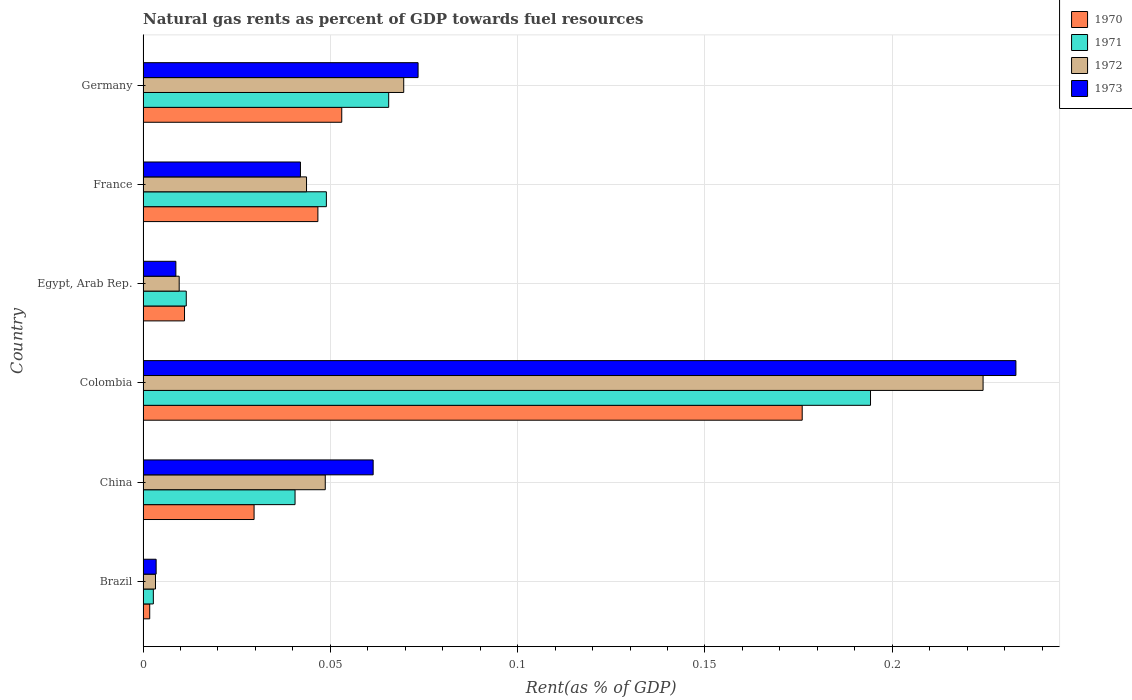How many different coloured bars are there?
Offer a terse response. 4. How many groups of bars are there?
Offer a very short reply. 6. Are the number of bars per tick equal to the number of legend labels?
Ensure brevity in your answer.  Yes. In how many cases, is the number of bars for a given country not equal to the number of legend labels?
Provide a short and direct response. 0. What is the matural gas rent in 1970 in Germany?
Your answer should be very brief. 0.05. Across all countries, what is the maximum matural gas rent in 1972?
Provide a succinct answer. 0.22. Across all countries, what is the minimum matural gas rent in 1971?
Your response must be concise. 0. In which country was the matural gas rent in 1973 maximum?
Your answer should be compact. Colombia. What is the total matural gas rent in 1972 in the graph?
Your response must be concise. 0.4. What is the difference between the matural gas rent in 1972 in Colombia and that in France?
Your answer should be compact. 0.18. What is the difference between the matural gas rent in 1972 in Egypt, Arab Rep. and the matural gas rent in 1970 in France?
Make the answer very short. -0.04. What is the average matural gas rent in 1972 per country?
Offer a very short reply. 0.07. What is the difference between the matural gas rent in 1971 and matural gas rent in 1973 in China?
Keep it short and to the point. -0.02. In how many countries, is the matural gas rent in 1972 greater than 0.09 %?
Your answer should be very brief. 1. What is the ratio of the matural gas rent in 1971 in Egypt, Arab Rep. to that in Germany?
Make the answer very short. 0.18. Is the matural gas rent in 1973 in Egypt, Arab Rep. less than that in Germany?
Give a very brief answer. Yes. Is the difference between the matural gas rent in 1971 in Colombia and France greater than the difference between the matural gas rent in 1973 in Colombia and France?
Your answer should be very brief. No. What is the difference between the highest and the second highest matural gas rent in 1972?
Make the answer very short. 0.15. What is the difference between the highest and the lowest matural gas rent in 1973?
Ensure brevity in your answer.  0.23. In how many countries, is the matural gas rent in 1970 greater than the average matural gas rent in 1970 taken over all countries?
Ensure brevity in your answer.  2. Is the sum of the matural gas rent in 1971 in Colombia and Germany greater than the maximum matural gas rent in 1972 across all countries?
Provide a short and direct response. Yes. Is it the case that in every country, the sum of the matural gas rent in 1970 and matural gas rent in 1971 is greater than the sum of matural gas rent in 1972 and matural gas rent in 1973?
Offer a very short reply. No. What does the 1st bar from the bottom in Germany represents?
Ensure brevity in your answer.  1970. How many bars are there?
Make the answer very short. 24. What is the difference between two consecutive major ticks on the X-axis?
Provide a succinct answer. 0.05. Does the graph contain any zero values?
Give a very brief answer. No. How are the legend labels stacked?
Make the answer very short. Vertical. What is the title of the graph?
Keep it short and to the point. Natural gas rents as percent of GDP towards fuel resources. Does "1979" appear as one of the legend labels in the graph?
Provide a short and direct response. No. What is the label or title of the X-axis?
Your response must be concise. Rent(as % of GDP). What is the Rent(as % of GDP) in 1970 in Brazil?
Your response must be concise. 0. What is the Rent(as % of GDP) in 1971 in Brazil?
Offer a terse response. 0. What is the Rent(as % of GDP) in 1972 in Brazil?
Your answer should be very brief. 0. What is the Rent(as % of GDP) of 1973 in Brazil?
Offer a terse response. 0. What is the Rent(as % of GDP) of 1970 in China?
Give a very brief answer. 0.03. What is the Rent(as % of GDP) in 1971 in China?
Provide a succinct answer. 0.04. What is the Rent(as % of GDP) in 1972 in China?
Ensure brevity in your answer.  0.05. What is the Rent(as % of GDP) of 1973 in China?
Provide a succinct answer. 0.06. What is the Rent(as % of GDP) of 1970 in Colombia?
Your response must be concise. 0.18. What is the Rent(as % of GDP) of 1971 in Colombia?
Provide a short and direct response. 0.19. What is the Rent(as % of GDP) in 1972 in Colombia?
Your answer should be compact. 0.22. What is the Rent(as % of GDP) of 1973 in Colombia?
Ensure brevity in your answer.  0.23. What is the Rent(as % of GDP) of 1970 in Egypt, Arab Rep.?
Your answer should be compact. 0.01. What is the Rent(as % of GDP) in 1971 in Egypt, Arab Rep.?
Make the answer very short. 0.01. What is the Rent(as % of GDP) in 1972 in Egypt, Arab Rep.?
Make the answer very short. 0.01. What is the Rent(as % of GDP) of 1973 in Egypt, Arab Rep.?
Offer a terse response. 0.01. What is the Rent(as % of GDP) of 1970 in France?
Give a very brief answer. 0.05. What is the Rent(as % of GDP) in 1971 in France?
Make the answer very short. 0.05. What is the Rent(as % of GDP) of 1972 in France?
Your answer should be very brief. 0.04. What is the Rent(as % of GDP) of 1973 in France?
Your answer should be compact. 0.04. What is the Rent(as % of GDP) in 1970 in Germany?
Your answer should be very brief. 0.05. What is the Rent(as % of GDP) in 1971 in Germany?
Offer a very short reply. 0.07. What is the Rent(as % of GDP) of 1972 in Germany?
Provide a succinct answer. 0.07. What is the Rent(as % of GDP) in 1973 in Germany?
Keep it short and to the point. 0.07. Across all countries, what is the maximum Rent(as % of GDP) in 1970?
Keep it short and to the point. 0.18. Across all countries, what is the maximum Rent(as % of GDP) in 1971?
Keep it short and to the point. 0.19. Across all countries, what is the maximum Rent(as % of GDP) in 1972?
Keep it short and to the point. 0.22. Across all countries, what is the maximum Rent(as % of GDP) of 1973?
Give a very brief answer. 0.23. Across all countries, what is the minimum Rent(as % of GDP) of 1970?
Make the answer very short. 0. Across all countries, what is the minimum Rent(as % of GDP) in 1971?
Keep it short and to the point. 0. Across all countries, what is the minimum Rent(as % of GDP) in 1972?
Ensure brevity in your answer.  0. Across all countries, what is the minimum Rent(as % of GDP) in 1973?
Make the answer very short. 0. What is the total Rent(as % of GDP) of 1970 in the graph?
Give a very brief answer. 0.32. What is the total Rent(as % of GDP) in 1971 in the graph?
Give a very brief answer. 0.36. What is the total Rent(as % of GDP) of 1972 in the graph?
Provide a short and direct response. 0.4. What is the total Rent(as % of GDP) of 1973 in the graph?
Your answer should be very brief. 0.42. What is the difference between the Rent(as % of GDP) in 1970 in Brazil and that in China?
Your answer should be very brief. -0.03. What is the difference between the Rent(as % of GDP) of 1971 in Brazil and that in China?
Your response must be concise. -0.04. What is the difference between the Rent(as % of GDP) in 1972 in Brazil and that in China?
Your answer should be very brief. -0.05. What is the difference between the Rent(as % of GDP) of 1973 in Brazil and that in China?
Provide a short and direct response. -0.06. What is the difference between the Rent(as % of GDP) of 1970 in Brazil and that in Colombia?
Offer a terse response. -0.17. What is the difference between the Rent(as % of GDP) of 1971 in Brazil and that in Colombia?
Keep it short and to the point. -0.19. What is the difference between the Rent(as % of GDP) in 1972 in Brazil and that in Colombia?
Provide a succinct answer. -0.22. What is the difference between the Rent(as % of GDP) in 1973 in Brazil and that in Colombia?
Your response must be concise. -0.23. What is the difference between the Rent(as % of GDP) of 1970 in Brazil and that in Egypt, Arab Rep.?
Give a very brief answer. -0.01. What is the difference between the Rent(as % of GDP) in 1971 in Brazil and that in Egypt, Arab Rep.?
Offer a terse response. -0.01. What is the difference between the Rent(as % of GDP) in 1972 in Brazil and that in Egypt, Arab Rep.?
Your response must be concise. -0.01. What is the difference between the Rent(as % of GDP) in 1973 in Brazil and that in Egypt, Arab Rep.?
Give a very brief answer. -0.01. What is the difference between the Rent(as % of GDP) of 1970 in Brazil and that in France?
Offer a very short reply. -0.04. What is the difference between the Rent(as % of GDP) in 1971 in Brazil and that in France?
Offer a very short reply. -0.05. What is the difference between the Rent(as % of GDP) in 1972 in Brazil and that in France?
Offer a very short reply. -0.04. What is the difference between the Rent(as % of GDP) in 1973 in Brazil and that in France?
Give a very brief answer. -0.04. What is the difference between the Rent(as % of GDP) in 1970 in Brazil and that in Germany?
Provide a succinct answer. -0.05. What is the difference between the Rent(as % of GDP) of 1971 in Brazil and that in Germany?
Provide a short and direct response. -0.06. What is the difference between the Rent(as % of GDP) of 1972 in Brazil and that in Germany?
Your answer should be very brief. -0.07. What is the difference between the Rent(as % of GDP) of 1973 in Brazil and that in Germany?
Offer a very short reply. -0.07. What is the difference between the Rent(as % of GDP) of 1970 in China and that in Colombia?
Give a very brief answer. -0.15. What is the difference between the Rent(as % of GDP) in 1971 in China and that in Colombia?
Your response must be concise. -0.15. What is the difference between the Rent(as % of GDP) in 1972 in China and that in Colombia?
Your response must be concise. -0.18. What is the difference between the Rent(as % of GDP) in 1973 in China and that in Colombia?
Provide a succinct answer. -0.17. What is the difference between the Rent(as % of GDP) in 1970 in China and that in Egypt, Arab Rep.?
Provide a succinct answer. 0.02. What is the difference between the Rent(as % of GDP) of 1971 in China and that in Egypt, Arab Rep.?
Your answer should be very brief. 0.03. What is the difference between the Rent(as % of GDP) of 1972 in China and that in Egypt, Arab Rep.?
Your answer should be compact. 0.04. What is the difference between the Rent(as % of GDP) in 1973 in China and that in Egypt, Arab Rep.?
Provide a succinct answer. 0.05. What is the difference between the Rent(as % of GDP) in 1970 in China and that in France?
Provide a short and direct response. -0.02. What is the difference between the Rent(as % of GDP) in 1971 in China and that in France?
Give a very brief answer. -0.01. What is the difference between the Rent(as % of GDP) of 1972 in China and that in France?
Give a very brief answer. 0.01. What is the difference between the Rent(as % of GDP) of 1973 in China and that in France?
Your answer should be compact. 0.02. What is the difference between the Rent(as % of GDP) in 1970 in China and that in Germany?
Your answer should be compact. -0.02. What is the difference between the Rent(as % of GDP) of 1971 in China and that in Germany?
Provide a succinct answer. -0.03. What is the difference between the Rent(as % of GDP) of 1972 in China and that in Germany?
Ensure brevity in your answer.  -0.02. What is the difference between the Rent(as % of GDP) of 1973 in China and that in Germany?
Give a very brief answer. -0.01. What is the difference between the Rent(as % of GDP) in 1970 in Colombia and that in Egypt, Arab Rep.?
Offer a terse response. 0.16. What is the difference between the Rent(as % of GDP) in 1971 in Colombia and that in Egypt, Arab Rep.?
Offer a terse response. 0.18. What is the difference between the Rent(as % of GDP) in 1972 in Colombia and that in Egypt, Arab Rep.?
Keep it short and to the point. 0.21. What is the difference between the Rent(as % of GDP) of 1973 in Colombia and that in Egypt, Arab Rep.?
Provide a succinct answer. 0.22. What is the difference between the Rent(as % of GDP) of 1970 in Colombia and that in France?
Keep it short and to the point. 0.13. What is the difference between the Rent(as % of GDP) of 1971 in Colombia and that in France?
Offer a very short reply. 0.15. What is the difference between the Rent(as % of GDP) in 1972 in Colombia and that in France?
Provide a succinct answer. 0.18. What is the difference between the Rent(as % of GDP) in 1973 in Colombia and that in France?
Keep it short and to the point. 0.19. What is the difference between the Rent(as % of GDP) in 1970 in Colombia and that in Germany?
Your answer should be compact. 0.12. What is the difference between the Rent(as % of GDP) in 1971 in Colombia and that in Germany?
Your answer should be compact. 0.13. What is the difference between the Rent(as % of GDP) in 1972 in Colombia and that in Germany?
Your answer should be very brief. 0.15. What is the difference between the Rent(as % of GDP) in 1973 in Colombia and that in Germany?
Offer a terse response. 0.16. What is the difference between the Rent(as % of GDP) of 1970 in Egypt, Arab Rep. and that in France?
Keep it short and to the point. -0.04. What is the difference between the Rent(as % of GDP) in 1971 in Egypt, Arab Rep. and that in France?
Your answer should be compact. -0.04. What is the difference between the Rent(as % of GDP) of 1972 in Egypt, Arab Rep. and that in France?
Provide a short and direct response. -0.03. What is the difference between the Rent(as % of GDP) in 1973 in Egypt, Arab Rep. and that in France?
Your answer should be very brief. -0.03. What is the difference between the Rent(as % of GDP) in 1970 in Egypt, Arab Rep. and that in Germany?
Ensure brevity in your answer.  -0.04. What is the difference between the Rent(as % of GDP) in 1971 in Egypt, Arab Rep. and that in Germany?
Keep it short and to the point. -0.05. What is the difference between the Rent(as % of GDP) of 1972 in Egypt, Arab Rep. and that in Germany?
Your answer should be compact. -0.06. What is the difference between the Rent(as % of GDP) in 1973 in Egypt, Arab Rep. and that in Germany?
Offer a very short reply. -0.06. What is the difference between the Rent(as % of GDP) in 1970 in France and that in Germany?
Provide a short and direct response. -0.01. What is the difference between the Rent(as % of GDP) in 1971 in France and that in Germany?
Offer a terse response. -0.02. What is the difference between the Rent(as % of GDP) of 1972 in France and that in Germany?
Offer a very short reply. -0.03. What is the difference between the Rent(as % of GDP) in 1973 in France and that in Germany?
Offer a very short reply. -0.03. What is the difference between the Rent(as % of GDP) of 1970 in Brazil and the Rent(as % of GDP) of 1971 in China?
Your response must be concise. -0.04. What is the difference between the Rent(as % of GDP) in 1970 in Brazil and the Rent(as % of GDP) in 1972 in China?
Your response must be concise. -0.05. What is the difference between the Rent(as % of GDP) in 1970 in Brazil and the Rent(as % of GDP) in 1973 in China?
Your answer should be very brief. -0.06. What is the difference between the Rent(as % of GDP) in 1971 in Brazil and the Rent(as % of GDP) in 1972 in China?
Provide a short and direct response. -0.05. What is the difference between the Rent(as % of GDP) in 1971 in Brazil and the Rent(as % of GDP) in 1973 in China?
Give a very brief answer. -0.06. What is the difference between the Rent(as % of GDP) in 1972 in Brazil and the Rent(as % of GDP) in 1973 in China?
Your answer should be very brief. -0.06. What is the difference between the Rent(as % of GDP) of 1970 in Brazil and the Rent(as % of GDP) of 1971 in Colombia?
Offer a terse response. -0.19. What is the difference between the Rent(as % of GDP) of 1970 in Brazil and the Rent(as % of GDP) of 1972 in Colombia?
Your answer should be compact. -0.22. What is the difference between the Rent(as % of GDP) of 1970 in Brazil and the Rent(as % of GDP) of 1973 in Colombia?
Provide a succinct answer. -0.23. What is the difference between the Rent(as % of GDP) in 1971 in Brazil and the Rent(as % of GDP) in 1972 in Colombia?
Offer a very short reply. -0.22. What is the difference between the Rent(as % of GDP) in 1971 in Brazil and the Rent(as % of GDP) in 1973 in Colombia?
Keep it short and to the point. -0.23. What is the difference between the Rent(as % of GDP) in 1972 in Brazil and the Rent(as % of GDP) in 1973 in Colombia?
Offer a terse response. -0.23. What is the difference between the Rent(as % of GDP) of 1970 in Brazil and the Rent(as % of GDP) of 1971 in Egypt, Arab Rep.?
Keep it short and to the point. -0.01. What is the difference between the Rent(as % of GDP) in 1970 in Brazil and the Rent(as % of GDP) in 1972 in Egypt, Arab Rep.?
Provide a short and direct response. -0.01. What is the difference between the Rent(as % of GDP) of 1970 in Brazil and the Rent(as % of GDP) of 1973 in Egypt, Arab Rep.?
Provide a succinct answer. -0.01. What is the difference between the Rent(as % of GDP) of 1971 in Brazil and the Rent(as % of GDP) of 1972 in Egypt, Arab Rep.?
Offer a terse response. -0.01. What is the difference between the Rent(as % of GDP) in 1971 in Brazil and the Rent(as % of GDP) in 1973 in Egypt, Arab Rep.?
Your response must be concise. -0.01. What is the difference between the Rent(as % of GDP) of 1972 in Brazil and the Rent(as % of GDP) of 1973 in Egypt, Arab Rep.?
Offer a very short reply. -0.01. What is the difference between the Rent(as % of GDP) of 1970 in Brazil and the Rent(as % of GDP) of 1971 in France?
Ensure brevity in your answer.  -0.05. What is the difference between the Rent(as % of GDP) of 1970 in Brazil and the Rent(as % of GDP) of 1972 in France?
Ensure brevity in your answer.  -0.04. What is the difference between the Rent(as % of GDP) of 1970 in Brazil and the Rent(as % of GDP) of 1973 in France?
Provide a succinct answer. -0.04. What is the difference between the Rent(as % of GDP) of 1971 in Brazil and the Rent(as % of GDP) of 1972 in France?
Offer a terse response. -0.04. What is the difference between the Rent(as % of GDP) in 1971 in Brazil and the Rent(as % of GDP) in 1973 in France?
Provide a short and direct response. -0.04. What is the difference between the Rent(as % of GDP) in 1972 in Brazil and the Rent(as % of GDP) in 1973 in France?
Give a very brief answer. -0.04. What is the difference between the Rent(as % of GDP) of 1970 in Brazil and the Rent(as % of GDP) of 1971 in Germany?
Give a very brief answer. -0.06. What is the difference between the Rent(as % of GDP) in 1970 in Brazil and the Rent(as % of GDP) in 1972 in Germany?
Your response must be concise. -0.07. What is the difference between the Rent(as % of GDP) of 1970 in Brazil and the Rent(as % of GDP) of 1973 in Germany?
Make the answer very short. -0.07. What is the difference between the Rent(as % of GDP) of 1971 in Brazil and the Rent(as % of GDP) of 1972 in Germany?
Your answer should be very brief. -0.07. What is the difference between the Rent(as % of GDP) of 1971 in Brazil and the Rent(as % of GDP) of 1973 in Germany?
Keep it short and to the point. -0.07. What is the difference between the Rent(as % of GDP) of 1972 in Brazil and the Rent(as % of GDP) of 1973 in Germany?
Your answer should be compact. -0.07. What is the difference between the Rent(as % of GDP) of 1970 in China and the Rent(as % of GDP) of 1971 in Colombia?
Provide a short and direct response. -0.16. What is the difference between the Rent(as % of GDP) of 1970 in China and the Rent(as % of GDP) of 1972 in Colombia?
Ensure brevity in your answer.  -0.19. What is the difference between the Rent(as % of GDP) in 1970 in China and the Rent(as % of GDP) in 1973 in Colombia?
Offer a terse response. -0.2. What is the difference between the Rent(as % of GDP) of 1971 in China and the Rent(as % of GDP) of 1972 in Colombia?
Your answer should be compact. -0.18. What is the difference between the Rent(as % of GDP) in 1971 in China and the Rent(as % of GDP) in 1973 in Colombia?
Make the answer very short. -0.19. What is the difference between the Rent(as % of GDP) in 1972 in China and the Rent(as % of GDP) in 1973 in Colombia?
Your answer should be very brief. -0.18. What is the difference between the Rent(as % of GDP) in 1970 in China and the Rent(as % of GDP) in 1971 in Egypt, Arab Rep.?
Keep it short and to the point. 0.02. What is the difference between the Rent(as % of GDP) in 1970 in China and the Rent(as % of GDP) in 1972 in Egypt, Arab Rep.?
Offer a very short reply. 0.02. What is the difference between the Rent(as % of GDP) of 1970 in China and the Rent(as % of GDP) of 1973 in Egypt, Arab Rep.?
Your response must be concise. 0.02. What is the difference between the Rent(as % of GDP) of 1971 in China and the Rent(as % of GDP) of 1972 in Egypt, Arab Rep.?
Your answer should be compact. 0.03. What is the difference between the Rent(as % of GDP) in 1971 in China and the Rent(as % of GDP) in 1973 in Egypt, Arab Rep.?
Your response must be concise. 0.03. What is the difference between the Rent(as % of GDP) in 1972 in China and the Rent(as % of GDP) in 1973 in Egypt, Arab Rep.?
Provide a succinct answer. 0.04. What is the difference between the Rent(as % of GDP) of 1970 in China and the Rent(as % of GDP) of 1971 in France?
Your answer should be compact. -0.02. What is the difference between the Rent(as % of GDP) in 1970 in China and the Rent(as % of GDP) in 1972 in France?
Provide a succinct answer. -0.01. What is the difference between the Rent(as % of GDP) in 1970 in China and the Rent(as % of GDP) in 1973 in France?
Keep it short and to the point. -0.01. What is the difference between the Rent(as % of GDP) in 1971 in China and the Rent(as % of GDP) in 1972 in France?
Provide a short and direct response. -0. What is the difference between the Rent(as % of GDP) in 1971 in China and the Rent(as % of GDP) in 1973 in France?
Offer a terse response. -0. What is the difference between the Rent(as % of GDP) of 1972 in China and the Rent(as % of GDP) of 1973 in France?
Provide a short and direct response. 0.01. What is the difference between the Rent(as % of GDP) of 1970 in China and the Rent(as % of GDP) of 1971 in Germany?
Offer a very short reply. -0.04. What is the difference between the Rent(as % of GDP) of 1970 in China and the Rent(as % of GDP) of 1972 in Germany?
Your answer should be compact. -0.04. What is the difference between the Rent(as % of GDP) of 1970 in China and the Rent(as % of GDP) of 1973 in Germany?
Ensure brevity in your answer.  -0.04. What is the difference between the Rent(as % of GDP) of 1971 in China and the Rent(as % of GDP) of 1972 in Germany?
Your answer should be compact. -0.03. What is the difference between the Rent(as % of GDP) of 1971 in China and the Rent(as % of GDP) of 1973 in Germany?
Offer a very short reply. -0.03. What is the difference between the Rent(as % of GDP) in 1972 in China and the Rent(as % of GDP) in 1973 in Germany?
Provide a short and direct response. -0.02. What is the difference between the Rent(as % of GDP) of 1970 in Colombia and the Rent(as % of GDP) of 1971 in Egypt, Arab Rep.?
Offer a very short reply. 0.16. What is the difference between the Rent(as % of GDP) in 1970 in Colombia and the Rent(as % of GDP) in 1972 in Egypt, Arab Rep.?
Offer a terse response. 0.17. What is the difference between the Rent(as % of GDP) in 1970 in Colombia and the Rent(as % of GDP) in 1973 in Egypt, Arab Rep.?
Make the answer very short. 0.17. What is the difference between the Rent(as % of GDP) of 1971 in Colombia and the Rent(as % of GDP) of 1972 in Egypt, Arab Rep.?
Your answer should be very brief. 0.18. What is the difference between the Rent(as % of GDP) in 1971 in Colombia and the Rent(as % of GDP) in 1973 in Egypt, Arab Rep.?
Your answer should be compact. 0.19. What is the difference between the Rent(as % of GDP) of 1972 in Colombia and the Rent(as % of GDP) of 1973 in Egypt, Arab Rep.?
Offer a very short reply. 0.22. What is the difference between the Rent(as % of GDP) in 1970 in Colombia and the Rent(as % of GDP) in 1971 in France?
Your response must be concise. 0.13. What is the difference between the Rent(as % of GDP) of 1970 in Colombia and the Rent(as % of GDP) of 1972 in France?
Make the answer very short. 0.13. What is the difference between the Rent(as % of GDP) of 1970 in Colombia and the Rent(as % of GDP) of 1973 in France?
Your answer should be very brief. 0.13. What is the difference between the Rent(as % of GDP) of 1971 in Colombia and the Rent(as % of GDP) of 1972 in France?
Give a very brief answer. 0.15. What is the difference between the Rent(as % of GDP) of 1971 in Colombia and the Rent(as % of GDP) of 1973 in France?
Ensure brevity in your answer.  0.15. What is the difference between the Rent(as % of GDP) in 1972 in Colombia and the Rent(as % of GDP) in 1973 in France?
Give a very brief answer. 0.18. What is the difference between the Rent(as % of GDP) of 1970 in Colombia and the Rent(as % of GDP) of 1971 in Germany?
Offer a very short reply. 0.11. What is the difference between the Rent(as % of GDP) in 1970 in Colombia and the Rent(as % of GDP) in 1972 in Germany?
Make the answer very short. 0.11. What is the difference between the Rent(as % of GDP) in 1970 in Colombia and the Rent(as % of GDP) in 1973 in Germany?
Your answer should be compact. 0.1. What is the difference between the Rent(as % of GDP) in 1971 in Colombia and the Rent(as % of GDP) in 1972 in Germany?
Provide a short and direct response. 0.12. What is the difference between the Rent(as % of GDP) of 1971 in Colombia and the Rent(as % of GDP) of 1973 in Germany?
Give a very brief answer. 0.12. What is the difference between the Rent(as % of GDP) of 1972 in Colombia and the Rent(as % of GDP) of 1973 in Germany?
Provide a succinct answer. 0.15. What is the difference between the Rent(as % of GDP) of 1970 in Egypt, Arab Rep. and the Rent(as % of GDP) of 1971 in France?
Make the answer very short. -0.04. What is the difference between the Rent(as % of GDP) of 1970 in Egypt, Arab Rep. and the Rent(as % of GDP) of 1972 in France?
Keep it short and to the point. -0.03. What is the difference between the Rent(as % of GDP) of 1970 in Egypt, Arab Rep. and the Rent(as % of GDP) of 1973 in France?
Your answer should be compact. -0.03. What is the difference between the Rent(as % of GDP) of 1971 in Egypt, Arab Rep. and the Rent(as % of GDP) of 1972 in France?
Offer a terse response. -0.03. What is the difference between the Rent(as % of GDP) of 1971 in Egypt, Arab Rep. and the Rent(as % of GDP) of 1973 in France?
Provide a short and direct response. -0.03. What is the difference between the Rent(as % of GDP) of 1972 in Egypt, Arab Rep. and the Rent(as % of GDP) of 1973 in France?
Your answer should be compact. -0.03. What is the difference between the Rent(as % of GDP) in 1970 in Egypt, Arab Rep. and the Rent(as % of GDP) in 1971 in Germany?
Make the answer very short. -0.05. What is the difference between the Rent(as % of GDP) in 1970 in Egypt, Arab Rep. and the Rent(as % of GDP) in 1972 in Germany?
Make the answer very short. -0.06. What is the difference between the Rent(as % of GDP) of 1970 in Egypt, Arab Rep. and the Rent(as % of GDP) of 1973 in Germany?
Offer a very short reply. -0.06. What is the difference between the Rent(as % of GDP) in 1971 in Egypt, Arab Rep. and the Rent(as % of GDP) in 1972 in Germany?
Your answer should be very brief. -0.06. What is the difference between the Rent(as % of GDP) of 1971 in Egypt, Arab Rep. and the Rent(as % of GDP) of 1973 in Germany?
Provide a succinct answer. -0.06. What is the difference between the Rent(as % of GDP) in 1972 in Egypt, Arab Rep. and the Rent(as % of GDP) in 1973 in Germany?
Offer a terse response. -0.06. What is the difference between the Rent(as % of GDP) of 1970 in France and the Rent(as % of GDP) of 1971 in Germany?
Your answer should be very brief. -0.02. What is the difference between the Rent(as % of GDP) of 1970 in France and the Rent(as % of GDP) of 1972 in Germany?
Your response must be concise. -0.02. What is the difference between the Rent(as % of GDP) in 1970 in France and the Rent(as % of GDP) in 1973 in Germany?
Keep it short and to the point. -0.03. What is the difference between the Rent(as % of GDP) in 1971 in France and the Rent(as % of GDP) in 1972 in Germany?
Provide a short and direct response. -0.02. What is the difference between the Rent(as % of GDP) in 1971 in France and the Rent(as % of GDP) in 1973 in Germany?
Your answer should be compact. -0.02. What is the difference between the Rent(as % of GDP) of 1972 in France and the Rent(as % of GDP) of 1973 in Germany?
Keep it short and to the point. -0.03. What is the average Rent(as % of GDP) of 1970 per country?
Keep it short and to the point. 0.05. What is the average Rent(as % of GDP) of 1971 per country?
Give a very brief answer. 0.06. What is the average Rent(as % of GDP) of 1972 per country?
Provide a short and direct response. 0.07. What is the average Rent(as % of GDP) of 1973 per country?
Your response must be concise. 0.07. What is the difference between the Rent(as % of GDP) in 1970 and Rent(as % of GDP) in 1971 in Brazil?
Your answer should be compact. -0. What is the difference between the Rent(as % of GDP) in 1970 and Rent(as % of GDP) in 1972 in Brazil?
Ensure brevity in your answer.  -0. What is the difference between the Rent(as % of GDP) in 1970 and Rent(as % of GDP) in 1973 in Brazil?
Your answer should be very brief. -0. What is the difference between the Rent(as % of GDP) in 1971 and Rent(as % of GDP) in 1972 in Brazil?
Offer a terse response. -0. What is the difference between the Rent(as % of GDP) in 1971 and Rent(as % of GDP) in 1973 in Brazil?
Your answer should be compact. -0. What is the difference between the Rent(as % of GDP) in 1972 and Rent(as % of GDP) in 1973 in Brazil?
Provide a succinct answer. -0. What is the difference between the Rent(as % of GDP) in 1970 and Rent(as % of GDP) in 1971 in China?
Make the answer very short. -0.01. What is the difference between the Rent(as % of GDP) of 1970 and Rent(as % of GDP) of 1972 in China?
Provide a short and direct response. -0.02. What is the difference between the Rent(as % of GDP) of 1970 and Rent(as % of GDP) of 1973 in China?
Keep it short and to the point. -0.03. What is the difference between the Rent(as % of GDP) of 1971 and Rent(as % of GDP) of 1972 in China?
Your response must be concise. -0.01. What is the difference between the Rent(as % of GDP) of 1971 and Rent(as % of GDP) of 1973 in China?
Make the answer very short. -0.02. What is the difference between the Rent(as % of GDP) in 1972 and Rent(as % of GDP) in 1973 in China?
Keep it short and to the point. -0.01. What is the difference between the Rent(as % of GDP) in 1970 and Rent(as % of GDP) in 1971 in Colombia?
Keep it short and to the point. -0.02. What is the difference between the Rent(as % of GDP) in 1970 and Rent(as % of GDP) in 1972 in Colombia?
Keep it short and to the point. -0.05. What is the difference between the Rent(as % of GDP) of 1970 and Rent(as % of GDP) of 1973 in Colombia?
Provide a short and direct response. -0.06. What is the difference between the Rent(as % of GDP) of 1971 and Rent(as % of GDP) of 1972 in Colombia?
Provide a short and direct response. -0.03. What is the difference between the Rent(as % of GDP) in 1971 and Rent(as % of GDP) in 1973 in Colombia?
Your response must be concise. -0.04. What is the difference between the Rent(as % of GDP) of 1972 and Rent(as % of GDP) of 1973 in Colombia?
Your answer should be very brief. -0.01. What is the difference between the Rent(as % of GDP) in 1970 and Rent(as % of GDP) in 1971 in Egypt, Arab Rep.?
Provide a succinct answer. -0. What is the difference between the Rent(as % of GDP) in 1970 and Rent(as % of GDP) in 1972 in Egypt, Arab Rep.?
Your answer should be compact. 0. What is the difference between the Rent(as % of GDP) in 1970 and Rent(as % of GDP) in 1973 in Egypt, Arab Rep.?
Provide a succinct answer. 0. What is the difference between the Rent(as % of GDP) of 1971 and Rent(as % of GDP) of 1972 in Egypt, Arab Rep.?
Give a very brief answer. 0. What is the difference between the Rent(as % of GDP) in 1971 and Rent(as % of GDP) in 1973 in Egypt, Arab Rep.?
Provide a succinct answer. 0. What is the difference between the Rent(as % of GDP) of 1972 and Rent(as % of GDP) of 1973 in Egypt, Arab Rep.?
Give a very brief answer. 0. What is the difference between the Rent(as % of GDP) of 1970 and Rent(as % of GDP) of 1971 in France?
Provide a succinct answer. -0. What is the difference between the Rent(as % of GDP) of 1970 and Rent(as % of GDP) of 1972 in France?
Your response must be concise. 0. What is the difference between the Rent(as % of GDP) of 1970 and Rent(as % of GDP) of 1973 in France?
Provide a succinct answer. 0. What is the difference between the Rent(as % of GDP) in 1971 and Rent(as % of GDP) in 1972 in France?
Keep it short and to the point. 0.01. What is the difference between the Rent(as % of GDP) of 1971 and Rent(as % of GDP) of 1973 in France?
Keep it short and to the point. 0.01. What is the difference between the Rent(as % of GDP) of 1972 and Rent(as % of GDP) of 1973 in France?
Keep it short and to the point. 0. What is the difference between the Rent(as % of GDP) in 1970 and Rent(as % of GDP) in 1971 in Germany?
Your answer should be very brief. -0.01. What is the difference between the Rent(as % of GDP) in 1970 and Rent(as % of GDP) in 1972 in Germany?
Keep it short and to the point. -0.02. What is the difference between the Rent(as % of GDP) of 1970 and Rent(as % of GDP) of 1973 in Germany?
Ensure brevity in your answer.  -0.02. What is the difference between the Rent(as % of GDP) of 1971 and Rent(as % of GDP) of 1972 in Germany?
Your response must be concise. -0. What is the difference between the Rent(as % of GDP) in 1971 and Rent(as % of GDP) in 1973 in Germany?
Keep it short and to the point. -0.01. What is the difference between the Rent(as % of GDP) in 1972 and Rent(as % of GDP) in 1973 in Germany?
Keep it short and to the point. -0. What is the ratio of the Rent(as % of GDP) in 1971 in Brazil to that in China?
Your answer should be compact. 0.07. What is the ratio of the Rent(as % of GDP) in 1972 in Brazil to that in China?
Offer a very short reply. 0.07. What is the ratio of the Rent(as % of GDP) in 1973 in Brazil to that in China?
Offer a very short reply. 0.06. What is the ratio of the Rent(as % of GDP) of 1970 in Brazil to that in Colombia?
Offer a very short reply. 0.01. What is the ratio of the Rent(as % of GDP) of 1971 in Brazil to that in Colombia?
Make the answer very short. 0.01. What is the ratio of the Rent(as % of GDP) of 1972 in Brazil to that in Colombia?
Offer a very short reply. 0.01. What is the ratio of the Rent(as % of GDP) in 1973 in Brazil to that in Colombia?
Offer a very short reply. 0.01. What is the ratio of the Rent(as % of GDP) in 1970 in Brazil to that in Egypt, Arab Rep.?
Offer a very short reply. 0.16. What is the ratio of the Rent(as % of GDP) of 1971 in Brazil to that in Egypt, Arab Rep.?
Provide a short and direct response. 0.24. What is the ratio of the Rent(as % of GDP) in 1972 in Brazil to that in Egypt, Arab Rep.?
Provide a short and direct response. 0.34. What is the ratio of the Rent(as % of GDP) of 1973 in Brazil to that in Egypt, Arab Rep.?
Your answer should be very brief. 0.4. What is the ratio of the Rent(as % of GDP) of 1970 in Brazil to that in France?
Keep it short and to the point. 0.04. What is the ratio of the Rent(as % of GDP) in 1971 in Brazil to that in France?
Offer a very short reply. 0.06. What is the ratio of the Rent(as % of GDP) in 1972 in Brazil to that in France?
Offer a very short reply. 0.08. What is the ratio of the Rent(as % of GDP) in 1973 in Brazil to that in France?
Give a very brief answer. 0.08. What is the ratio of the Rent(as % of GDP) of 1970 in Brazil to that in Germany?
Your response must be concise. 0.03. What is the ratio of the Rent(as % of GDP) in 1971 in Brazil to that in Germany?
Provide a short and direct response. 0.04. What is the ratio of the Rent(as % of GDP) in 1972 in Brazil to that in Germany?
Provide a succinct answer. 0.05. What is the ratio of the Rent(as % of GDP) in 1973 in Brazil to that in Germany?
Provide a short and direct response. 0.05. What is the ratio of the Rent(as % of GDP) in 1970 in China to that in Colombia?
Provide a succinct answer. 0.17. What is the ratio of the Rent(as % of GDP) in 1971 in China to that in Colombia?
Keep it short and to the point. 0.21. What is the ratio of the Rent(as % of GDP) of 1972 in China to that in Colombia?
Keep it short and to the point. 0.22. What is the ratio of the Rent(as % of GDP) of 1973 in China to that in Colombia?
Offer a very short reply. 0.26. What is the ratio of the Rent(as % of GDP) of 1970 in China to that in Egypt, Arab Rep.?
Provide a short and direct response. 2.68. What is the ratio of the Rent(as % of GDP) in 1971 in China to that in Egypt, Arab Rep.?
Your answer should be very brief. 3.52. What is the ratio of the Rent(as % of GDP) of 1972 in China to that in Egypt, Arab Rep.?
Make the answer very short. 5.04. What is the ratio of the Rent(as % of GDP) of 1973 in China to that in Egypt, Arab Rep.?
Provide a succinct answer. 7.01. What is the ratio of the Rent(as % of GDP) of 1970 in China to that in France?
Give a very brief answer. 0.64. What is the ratio of the Rent(as % of GDP) of 1971 in China to that in France?
Your answer should be compact. 0.83. What is the ratio of the Rent(as % of GDP) of 1972 in China to that in France?
Make the answer very short. 1.11. What is the ratio of the Rent(as % of GDP) in 1973 in China to that in France?
Give a very brief answer. 1.46. What is the ratio of the Rent(as % of GDP) of 1970 in China to that in Germany?
Give a very brief answer. 0.56. What is the ratio of the Rent(as % of GDP) in 1971 in China to that in Germany?
Provide a short and direct response. 0.62. What is the ratio of the Rent(as % of GDP) in 1972 in China to that in Germany?
Ensure brevity in your answer.  0.7. What is the ratio of the Rent(as % of GDP) of 1973 in China to that in Germany?
Offer a very short reply. 0.84. What is the ratio of the Rent(as % of GDP) of 1970 in Colombia to that in Egypt, Arab Rep.?
Keep it short and to the point. 15.9. What is the ratio of the Rent(as % of GDP) of 1971 in Colombia to that in Egypt, Arab Rep.?
Your response must be concise. 16.84. What is the ratio of the Rent(as % of GDP) of 1972 in Colombia to that in Egypt, Arab Rep.?
Provide a short and direct response. 23.25. What is the ratio of the Rent(as % of GDP) of 1973 in Colombia to that in Egypt, Arab Rep.?
Give a very brief answer. 26.6. What is the ratio of the Rent(as % of GDP) in 1970 in Colombia to that in France?
Make the answer very short. 3.77. What is the ratio of the Rent(as % of GDP) in 1971 in Colombia to that in France?
Offer a terse response. 3.97. What is the ratio of the Rent(as % of GDP) of 1972 in Colombia to that in France?
Keep it short and to the point. 5.14. What is the ratio of the Rent(as % of GDP) of 1973 in Colombia to that in France?
Your answer should be very brief. 5.55. What is the ratio of the Rent(as % of GDP) in 1970 in Colombia to that in Germany?
Ensure brevity in your answer.  3.32. What is the ratio of the Rent(as % of GDP) in 1971 in Colombia to that in Germany?
Keep it short and to the point. 2.96. What is the ratio of the Rent(as % of GDP) of 1972 in Colombia to that in Germany?
Offer a terse response. 3.22. What is the ratio of the Rent(as % of GDP) in 1973 in Colombia to that in Germany?
Your response must be concise. 3.17. What is the ratio of the Rent(as % of GDP) of 1970 in Egypt, Arab Rep. to that in France?
Your response must be concise. 0.24. What is the ratio of the Rent(as % of GDP) in 1971 in Egypt, Arab Rep. to that in France?
Provide a short and direct response. 0.24. What is the ratio of the Rent(as % of GDP) of 1972 in Egypt, Arab Rep. to that in France?
Provide a short and direct response. 0.22. What is the ratio of the Rent(as % of GDP) in 1973 in Egypt, Arab Rep. to that in France?
Ensure brevity in your answer.  0.21. What is the ratio of the Rent(as % of GDP) in 1970 in Egypt, Arab Rep. to that in Germany?
Your answer should be compact. 0.21. What is the ratio of the Rent(as % of GDP) in 1971 in Egypt, Arab Rep. to that in Germany?
Give a very brief answer. 0.18. What is the ratio of the Rent(as % of GDP) of 1972 in Egypt, Arab Rep. to that in Germany?
Your answer should be compact. 0.14. What is the ratio of the Rent(as % of GDP) in 1973 in Egypt, Arab Rep. to that in Germany?
Your response must be concise. 0.12. What is the ratio of the Rent(as % of GDP) of 1970 in France to that in Germany?
Provide a succinct answer. 0.88. What is the ratio of the Rent(as % of GDP) in 1971 in France to that in Germany?
Your answer should be very brief. 0.75. What is the ratio of the Rent(as % of GDP) of 1972 in France to that in Germany?
Give a very brief answer. 0.63. What is the ratio of the Rent(as % of GDP) in 1973 in France to that in Germany?
Keep it short and to the point. 0.57. What is the difference between the highest and the second highest Rent(as % of GDP) in 1970?
Your answer should be very brief. 0.12. What is the difference between the highest and the second highest Rent(as % of GDP) of 1971?
Offer a terse response. 0.13. What is the difference between the highest and the second highest Rent(as % of GDP) in 1972?
Provide a short and direct response. 0.15. What is the difference between the highest and the second highest Rent(as % of GDP) of 1973?
Offer a terse response. 0.16. What is the difference between the highest and the lowest Rent(as % of GDP) of 1970?
Keep it short and to the point. 0.17. What is the difference between the highest and the lowest Rent(as % of GDP) of 1971?
Make the answer very short. 0.19. What is the difference between the highest and the lowest Rent(as % of GDP) of 1972?
Provide a short and direct response. 0.22. What is the difference between the highest and the lowest Rent(as % of GDP) in 1973?
Keep it short and to the point. 0.23. 